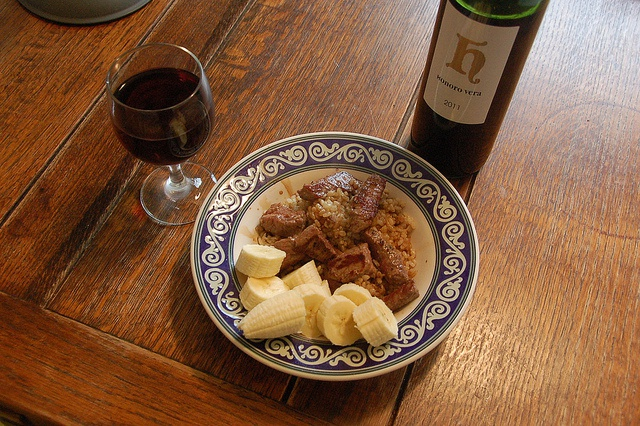Describe the objects in this image and their specific colors. I can see dining table in maroon, gray, brown, and tan tones, bowl in maroon, black, tan, and brown tones, bottle in maroon, black, gray, and olive tones, wine glass in maroon, black, and brown tones, and banana in maroon, tan, and olive tones in this image. 